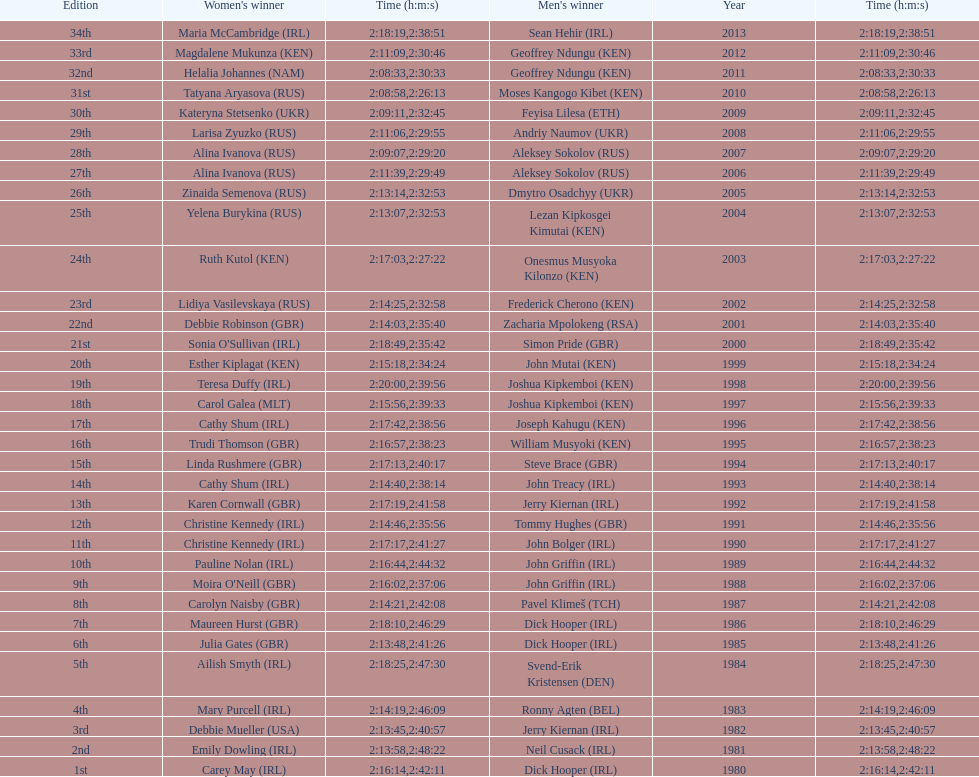Who won at least 3 times in the mens? Dick Hooper (IRL). 